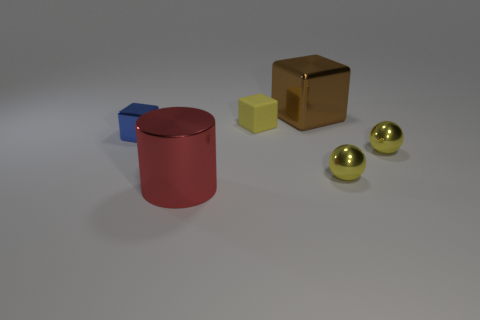Subtract all red balls. Subtract all purple cylinders. How many balls are left? 2 Add 1 large cyan metal objects. How many objects exist? 7 Subtract all cylinders. How many objects are left? 5 Subtract all yellow metal balls. Subtract all tiny blue objects. How many objects are left? 3 Add 6 large brown blocks. How many large brown blocks are left? 7 Add 3 blue blocks. How many blue blocks exist? 4 Subtract 0 blue cylinders. How many objects are left? 6 